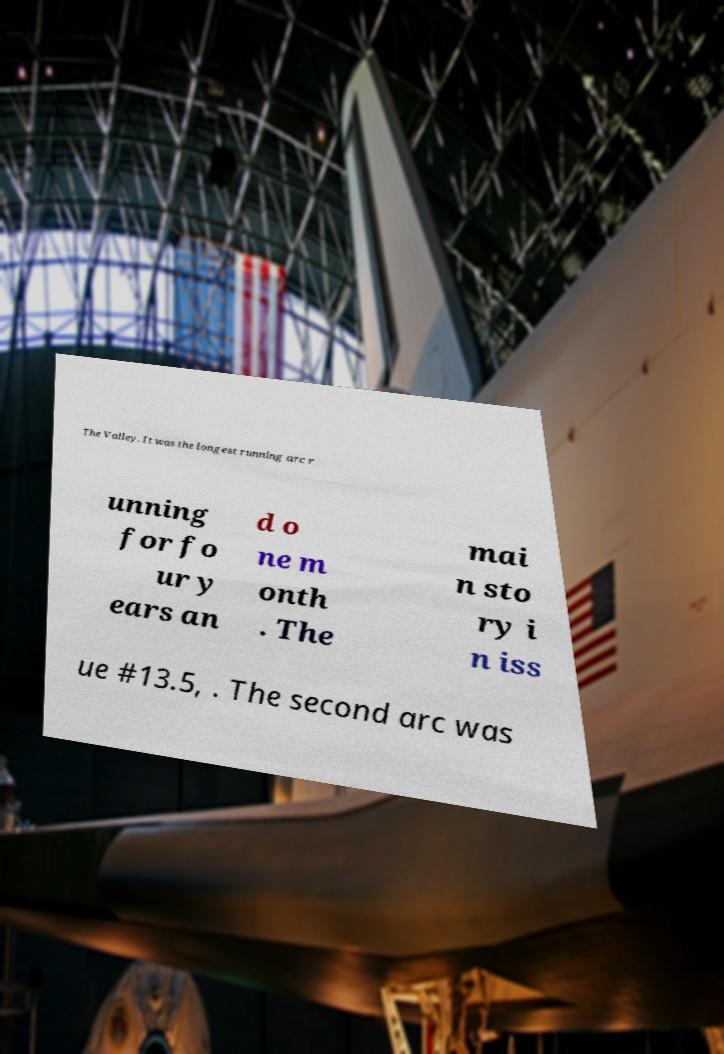I need the written content from this picture converted into text. Can you do that? The Valley. It was the longest running arc r unning for fo ur y ears an d o ne m onth . The mai n sto ry i n iss ue #13.5, . The second arc was 